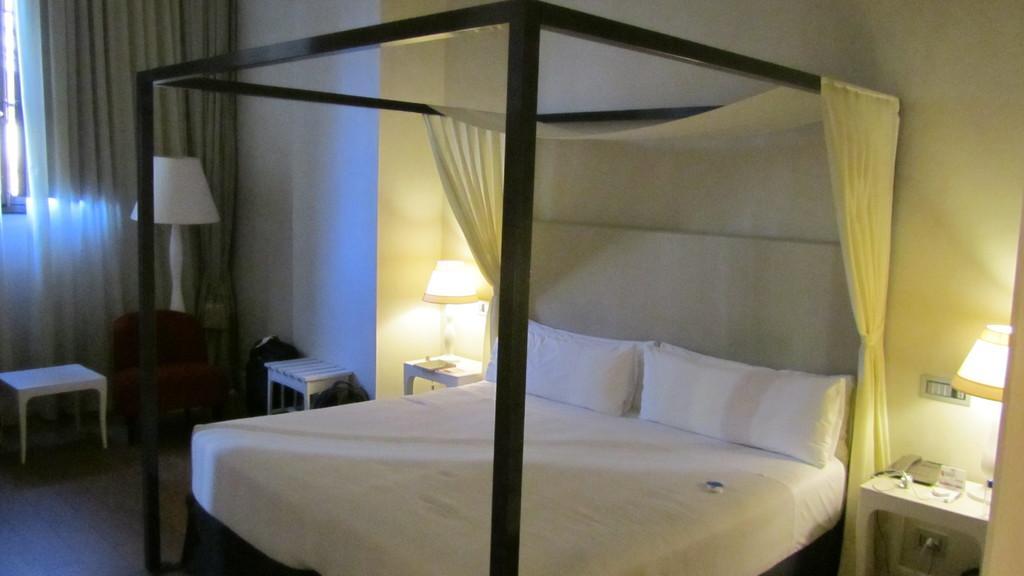Could you give a brief overview of what you see in this image? In this image I see the bed over here and I see few pillows and I see 4 stools on which there are few things and I see 2 lamps and I see another lamp over here and I see the curtains and I see the wall. 